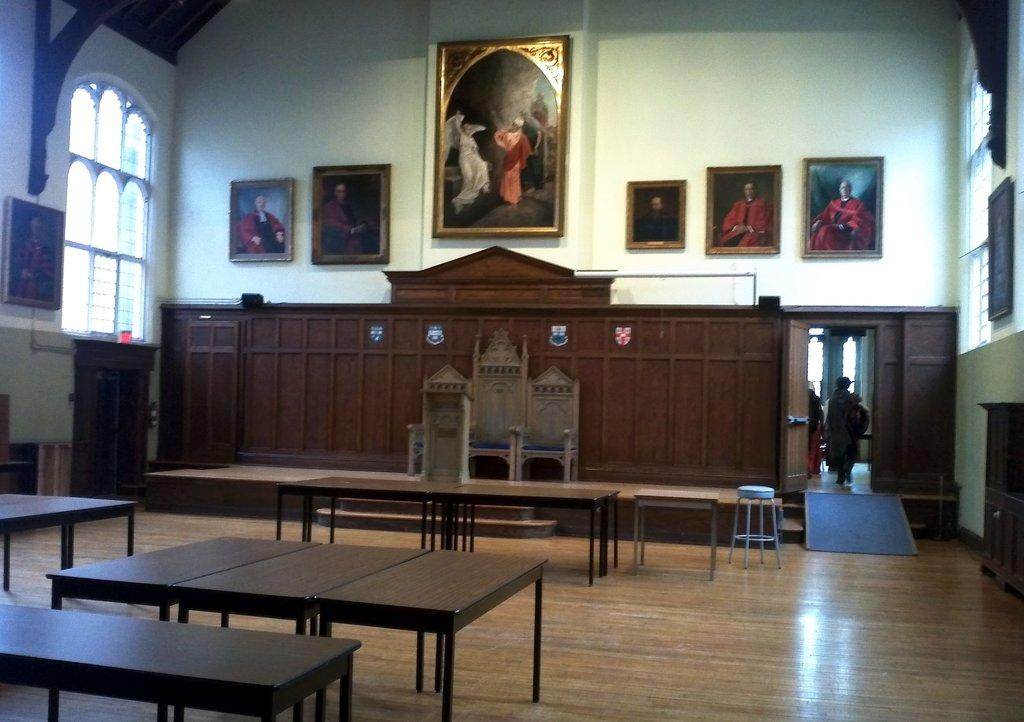What are the persons in the image doing? The persons in the image are walking from a door. What type of furniture can be seen in the image? There are tables, stools, and chairs in the image. What architectural features are present in the image? There are windows and frames on the walls in the image. What is the purpose of the podium in the image? The podium in the image may be used for presentations or speeches. Can you see any waves crashing against the shore in the image? There are no waves or shore visible in the image; it does not depict a beach or any body of water. 